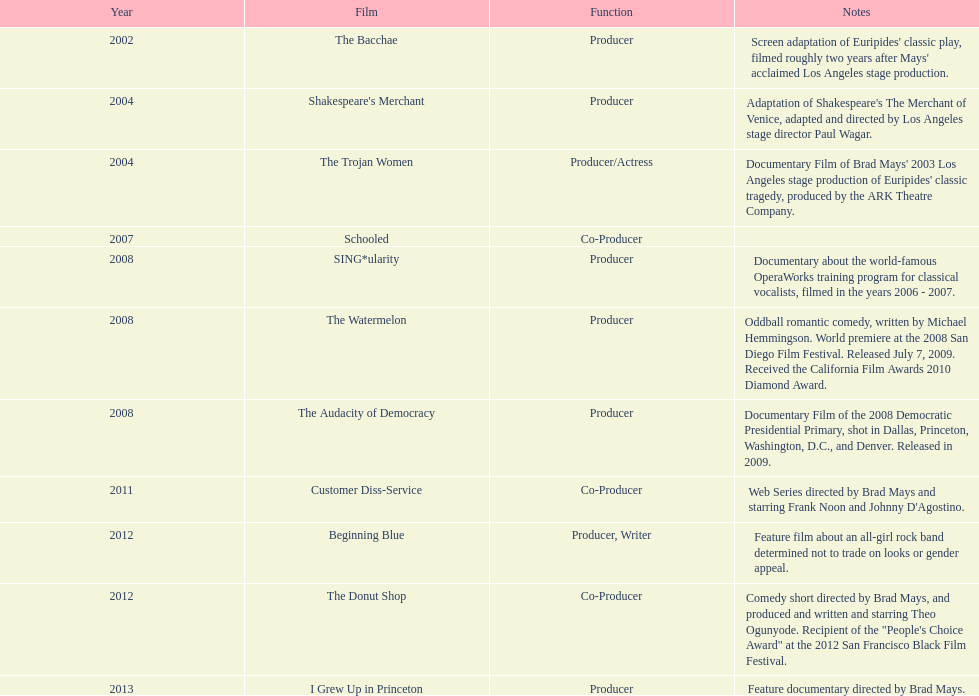Who was the initial producer responsible for creating the movie sing*ularity? Lorenda Starfelt. 